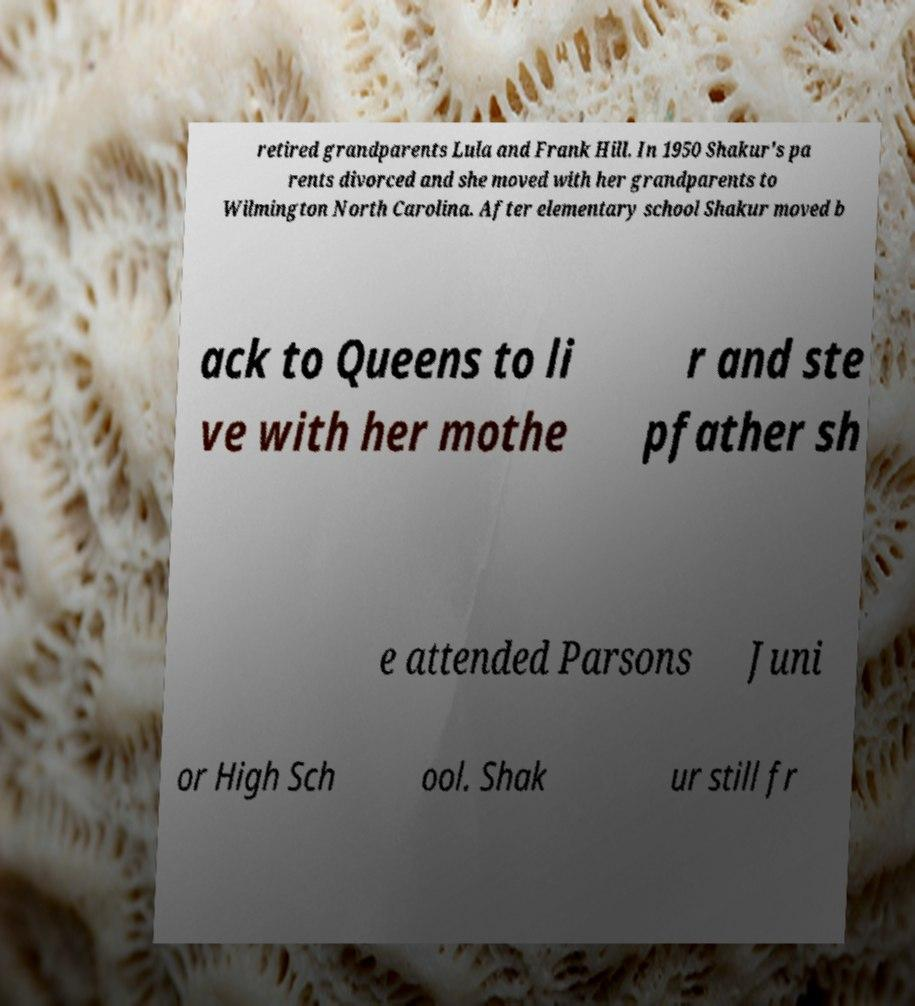For documentation purposes, I need the text within this image transcribed. Could you provide that? retired grandparents Lula and Frank Hill. In 1950 Shakur's pa rents divorced and she moved with her grandparents to Wilmington North Carolina. After elementary school Shakur moved b ack to Queens to li ve with her mothe r and ste pfather sh e attended Parsons Juni or High Sch ool. Shak ur still fr 